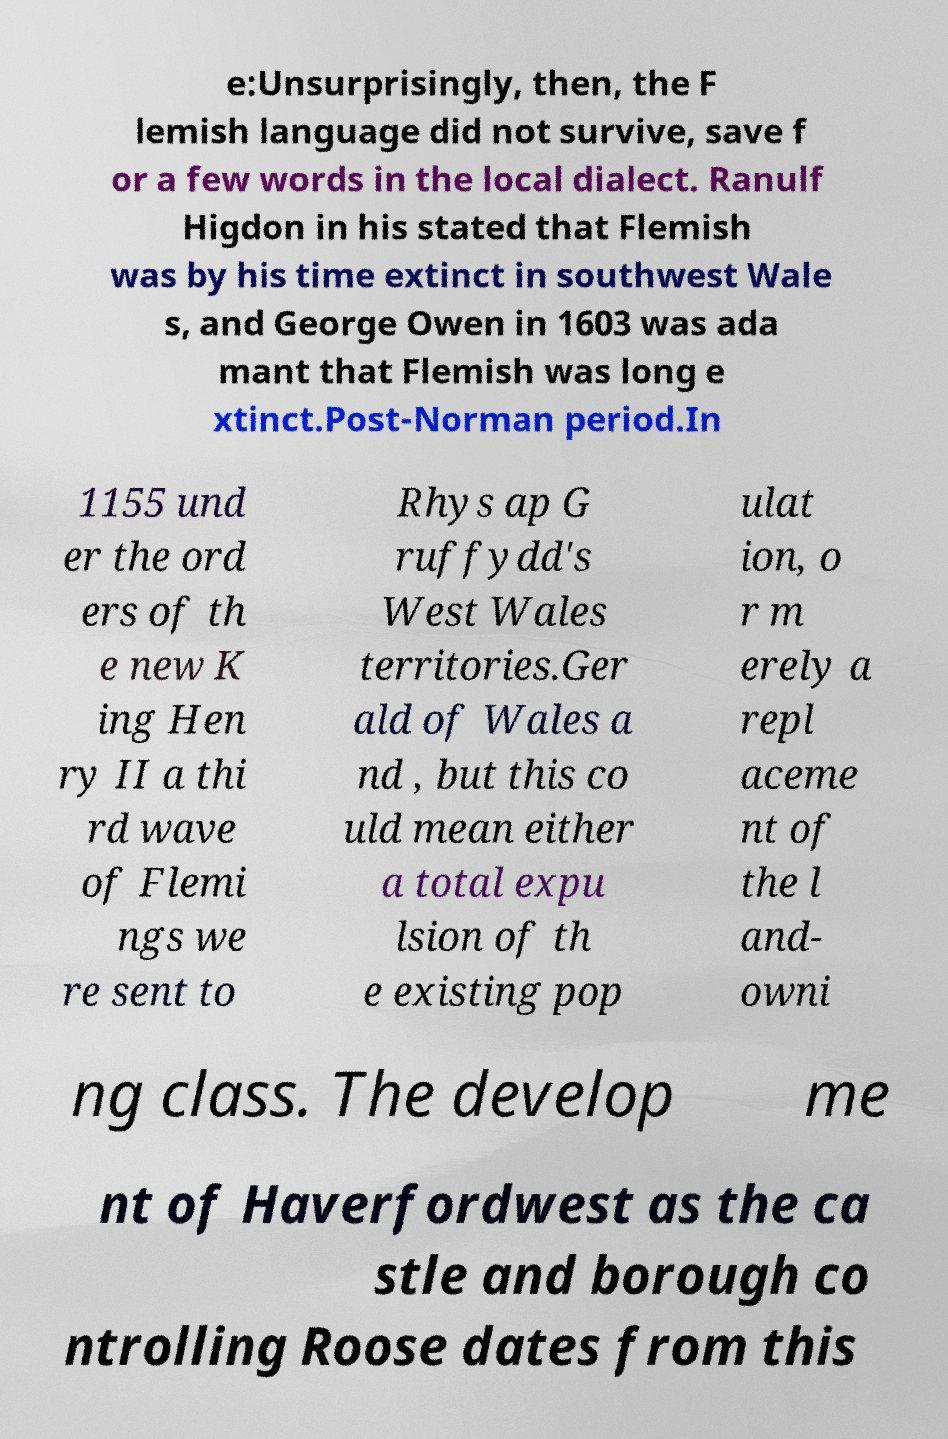For documentation purposes, I need the text within this image transcribed. Could you provide that? e:Unsurprisingly, then, the F lemish language did not survive, save f or a few words in the local dialect. Ranulf Higdon in his stated that Flemish was by his time extinct in southwest Wale s, and George Owen in 1603 was ada mant that Flemish was long e xtinct.Post-Norman period.In 1155 und er the ord ers of th e new K ing Hen ry II a thi rd wave of Flemi ngs we re sent to Rhys ap G ruffydd's West Wales territories.Ger ald of Wales a nd , but this co uld mean either a total expu lsion of th e existing pop ulat ion, o r m erely a repl aceme nt of the l and- owni ng class. The develop me nt of Haverfordwest as the ca stle and borough co ntrolling Roose dates from this 